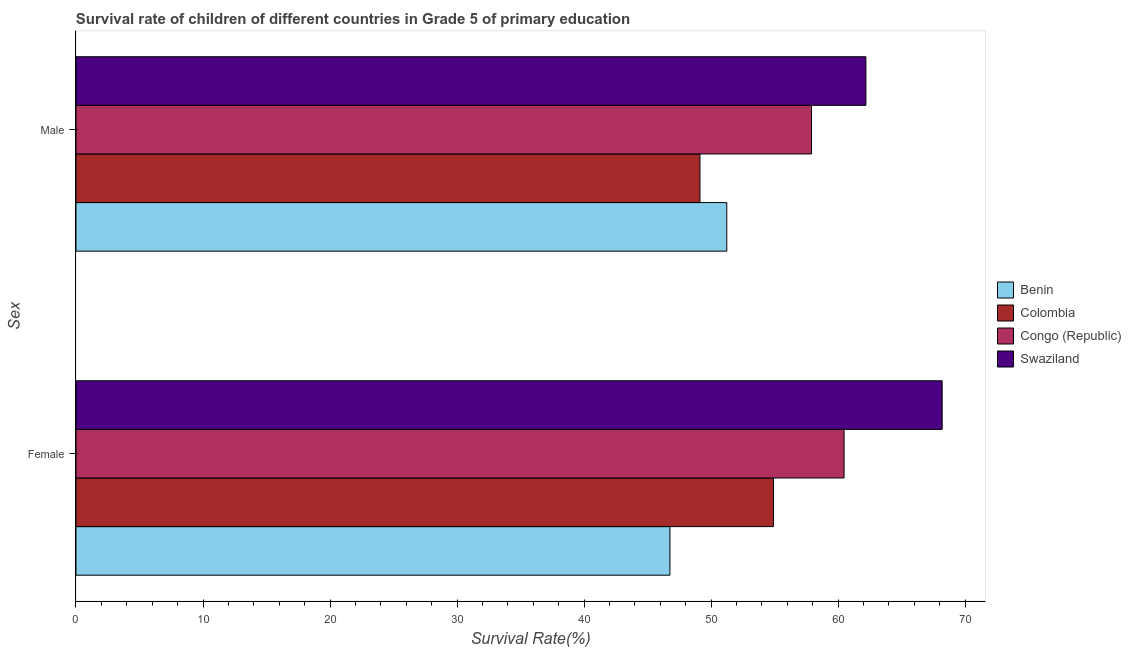Are the number of bars per tick equal to the number of legend labels?
Offer a terse response. Yes. Are the number of bars on each tick of the Y-axis equal?
Your answer should be compact. Yes. How many bars are there on the 2nd tick from the top?
Give a very brief answer. 4. How many bars are there on the 1st tick from the bottom?
Offer a very short reply. 4. What is the survival rate of male students in primary education in Congo (Republic)?
Your answer should be very brief. 57.91. Across all countries, what is the maximum survival rate of male students in primary education?
Your answer should be very brief. 62.19. Across all countries, what is the minimum survival rate of female students in primary education?
Provide a short and direct response. 46.76. In which country was the survival rate of female students in primary education maximum?
Give a very brief answer. Swaziland. In which country was the survival rate of male students in primary education minimum?
Make the answer very short. Colombia. What is the total survival rate of male students in primary education in the graph?
Give a very brief answer. 220.45. What is the difference between the survival rate of male students in primary education in Swaziland and that in Colombia?
Your answer should be compact. 13.06. What is the difference between the survival rate of female students in primary education in Swaziland and the survival rate of male students in primary education in Colombia?
Make the answer very short. 19.07. What is the average survival rate of female students in primary education per country?
Provide a short and direct response. 57.58. What is the difference between the survival rate of female students in primary education and survival rate of male students in primary education in Colombia?
Offer a very short reply. 5.79. In how many countries, is the survival rate of male students in primary education greater than 54 %?
Provide a short and direct response. 2. What is the ratio of the survival rate of male students in primary education in Congo (Republic) to that in Colombia?
Ensure brevity in your answer.  1.18. Is the survival rate of male students in primary education in Swaziland less than that in Congo (Republic)?
Make the answer very short. No. In how many countries, is the survival rate of male students in primary education greater than the average survival rate of male students in primary education taken over all countries?
Make the answer very short. 2. What does the 2nd bar from the top in Male represents?
Provide a succinct answer. Congo (Republic). What does the 4th bar from the bottom in Female represents?
Your response must be concise. Swaziland. Are all the bars in the graph horizontal?
Your answer should be compact. Yes. How many countries are there in the graph?
Provide a short and direct response. 4. What is the difference between two consecutive major ticks on the X-axis?
Provide a succinct answer. 10. Are the values on the major ticks of X-axis written in scientific E-notation?
Your answer should be very brief. No. Does the graph contain any zero values?
Give a very brief answer. No. Does the graph contain grids?
Your answer should be very brief. No. Where does the legend appear in the graph?
Keep it short and to the point. Center right. What is the title of the graph?
Offer a terse response. Survival rate of children of different countries in Grade 5 of primary education. What is the label or title of the X-axis?
Offer a terse response. Survival Rate(%). What is the label or title of the Y-axis?
Your response must be concise. Sex. What is the Survival Rate(%) of Benin in Female?
Keep it short and to the point. 46.76. What is the Survival Rate(%) in Colombia in Female?
Give a very brief answer. 54.91. What is the Survival Rate(%) of Congo (Republic) in Female?
Your response must be concise. 60.47. What is the Survival Rate(%) in Swaziland in Female?
Provide a succinct answer. 68.19. What is the Survival Rate(%) in Benin in Male?
Provide a succinct answer. 51.23. What is the Survival Rate(%) of Colombia in Male?
Provide a succinct answer. 49.12. What is the Survival Rate(%) of Congo (Republic) in Male?
Your answer should be very brief. 57.91. What is the Survival Rate(%) of Swaziland in Male?
Ensure brevity in your answer.  62.19. Across all Sex, what is the maximum Survival Rate(%) of Benin?
Offer a terse response. 51.23. Across all Sex, what is the maximum Survival Rate(%) of Colombia?
Give a very brief answer. 54.91. Across all Sex, what is the maximum Survival Rate(%) in Congo (Republic)?
Ensure brevity in your answer.  60.47. Across all Sex, what is the maximum Survival Rate(%) in Swaziland?
Give a very brief answer. 68.19. Across all Sex, what is the minimum Survival Rate(%) in Benin?
Make the answer very short. 46.76. Across all Sex, what is the minimum Survival Rate(%) of Colombia?
Ensure brevity in your answer.  49.12. Across all Sex, what is the minimum Survival Rate(%) of Congo (Republic)?
Offer a terse response. 57.91. Across all Sex, what is the minimum Survival Rate(%) in Swaziland?
Your answer should be very brief. 62.19. What is the total Survival Rate(%) of Benin in the graph?
Your answer should be very brief. 97.99. What is the total Survival Rate(%) in Colombia in the graph?
Give a very brief answer. 104.03. What is the total Survival Rate(%) in Congo (Republic) in the graph?
Provide a succinct answer. 118.38. What is the total Survival Rate(%) in Swaziland in the graph?
Make the answer very short. 130.38. What is the difference between the Survival Rate(%) in Benin in Female and that in Male?
Keep it short and to the point. -4.47. What is the difference between the Survival Rate(%) in Colombia in Female and that in Male?
Make the answer very short. 5.79. What is the difference between the Survival Rate(%) of Congo (Republic) in Female and that in Male?
Offer a terse response. 2.56. What is the difference between the Survival Rate(%) of Swaziland in Female and that in Male?
Keep it short and to the point. 6. What is the difference between the Survival Rate(%) of Benin in Female and the Survival Rate(%) of Colombia in Male?
Offer a terse response. -2.36. What is the difference between the Survival Rate(%) in Benin in Female and the Survival Rate(%) in Congo (Republic) in Male?
Provide a short and direct response. -11.15. What is the difference between the Survival Rate(%) in Benin in Female and the Survival Rate(%) in Swaziland in Male?
Your answer should be very brief. -15.43. What is the difference between the Survival Rate(%) in Colombia in Female and the Survival Rate(%) in Congo (Republic) in Male?
Ensure brevity in your answer.  -3. What is the difference between the Survival Rate(%) of Colombia in Female and the Survival Rate(%) of Swaziland in Male?
Your response must be concise. -7.28. What is the difference between the Survival Rate(%) in Congo (Republic) in Female and the Survival Rate(%) in Swaziland in Male?
Give a very brief answer. -1.72. What is the average Survival Rate(%) in Benin per Sex?
Offer a terse response. 49. What is the average Survival Rate(%) in Colombia per Sex?
Make the answer very short. 52.01. What is the average Survival Rate(%) of Congo (Republic) per Sex?
Your response must be concise. 59.19. What is the average Survival Rate(%) of Swaziland per Sex?
Provide a succinct answer. 65.19. What is the difference between the Survival Rate(%) in Benin and Survival Rate(%) in Colombia in Female?
Provide a short and direct response. -8.15. What is the difference between the Survival Rate(%) in Benin and Survival Rate(%) in Congo (Republic) in Female?
Make the answer very short. -13.71. What is the difference between the Survival Rate(%) in Benin and Survival Rate(%) in Swaziland in Female?
Provide a succinct answer. -21.43. What is the difference between the Survival Rate(%) in Colombia and Survival Rate(%) in Congo (Republic) in Female?
Provide a short and direct response. -5.56. What is the difference between the Survival Rate(%) of Colombia and Survival Rate(%) of Swaziland in Female?
Provide a succinct answer. -13.28. What is the difference between the Survival Rate(%) of Congo (Republic) and Survival Rate(%) of Swaziland in Female?
Keep it short and to the point. -7.72. What is the difference between the Survival Rate(%) of Benin and Survival Rate(%) of Colombia in Male?
Keep it short and to the point. 2.11. What is the difference between the Survival Rate(%) of Benin and Survival Rate(%) of Congo (Republic) in Male?
Provide a succinct answer. -6.67. What is the difference between the Survival Rate(%) of Benin and Survival Rate(%) of Swaziland in Male?
Provide a short and direct response. -10.95. What is the difference between the Survival Rate(%) of Colombia and Survival Rate(%) of Congo (Republic) in Male?
Provide a short and direct response. -8.79. What is the difference between the Survival Rate(%) in Colombia and Survival Rate(%) in Swaziland in Male?
Keep it short and to the point. -13.06. What is the difference between the Survival Rate(%) in Congo (Republic) and Survival Rate(%) in Swaziland in Male?
Provide a short and direct response. -4.28. What is the ratio of the Survival Rate(%) in Benin in Female to that in Male?
Your response must be concise. 0.91. What is the ratio of the Survival Rate(%) in Colombia in Female to that in Male?
Offer a very short reply. 1.12. What is the ratio of the Survival Rate(%) of Congo (Republic) in Female to that in Male?
Your answer should be very brief. 1.04. What is the ratio of the Survival Rate(%) of Swaziland in Female to that in Male?
Keep it short and to the point. 1.1. What is the difference between the highest and the second highest Survival Rate(%) of Benin?
Provide a succinct answer. 4.47. What is the difference between the highest and the second highest Survival Rate(%) in Colombia?
Make the answer very short. 5.79. What is the difference between the highest and the second highest Survival Rate(%) of Congo (Republic)?
Keep it short and to the point. 2.56. What is the difference between the highest and the second highest Survival Rate(%) of Swaziland?
Your answer should be compact. 6. What is the difference between the highest and the lowest Survival Rate(%) in Benin?
Your answer should be compact. 4.47. What is the difference between the highest and the lowest Survival Rate(%) in Colombia?
Your response must be concise. 5.79. What is the difference between the highest and the lowest Survival Rate(%) of Congo (Republic)?
Offer a very short reply. 2.56. What is the difference between the highest and the lowest Survival Rate(%) in Swaziland?
Your answer should be compact. 6. 